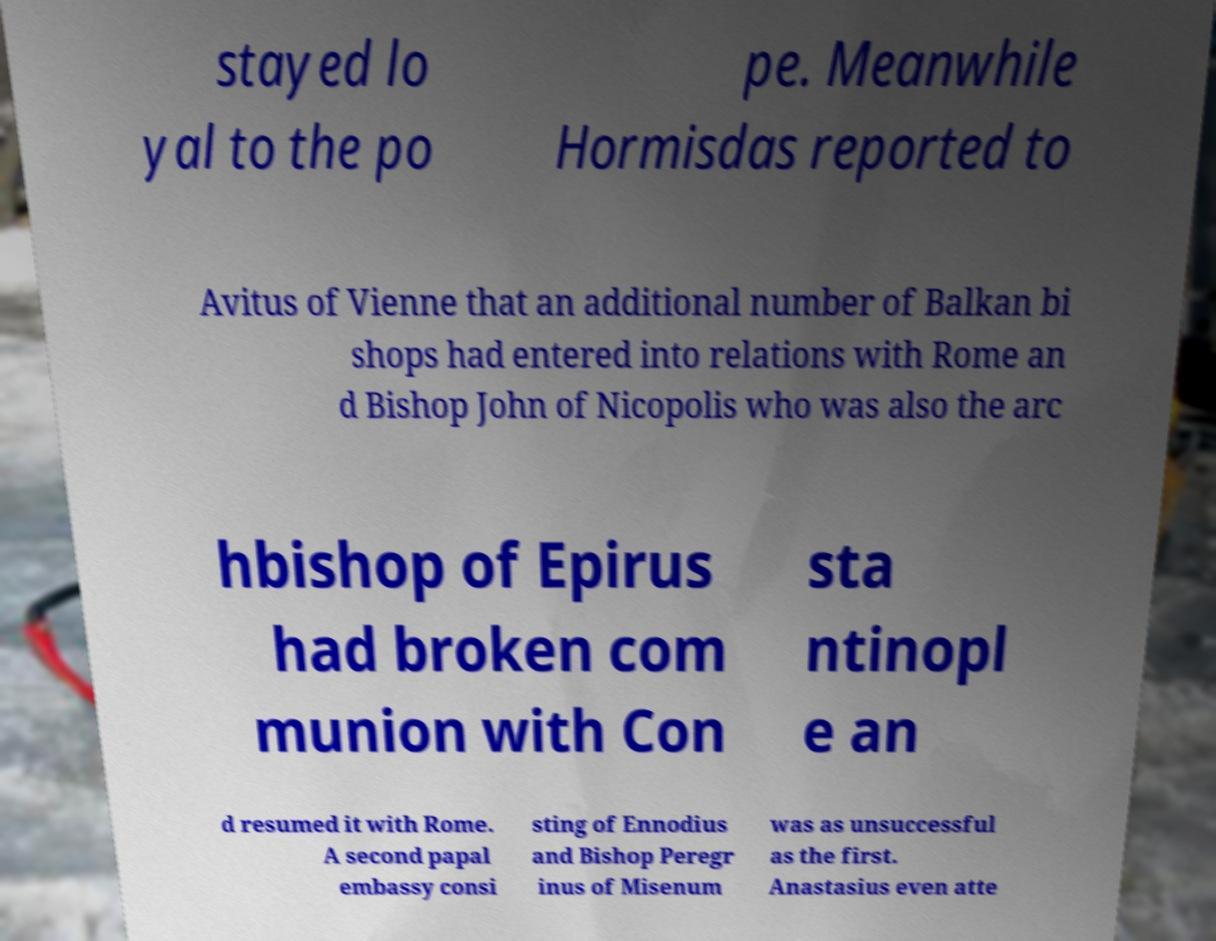What messages or text are displayed in this image? I need them in a readable, typed format. stayed lo yal to the po pe. Meanwhile Hormisdas reported to Avitus of Vienne that an additional number of Balkan bi shops had entered into relations with Rome an d Bishop John of Nicopolis who was also the arc hbishop of Epirus had broken com munion with Con sta ntinopl e an d resumed it with Rome. A second papal embassy consi sting of Ennodius and Bishop Peregr inus of Misenum was as unsuccessful as the first. Anastasius even atte 